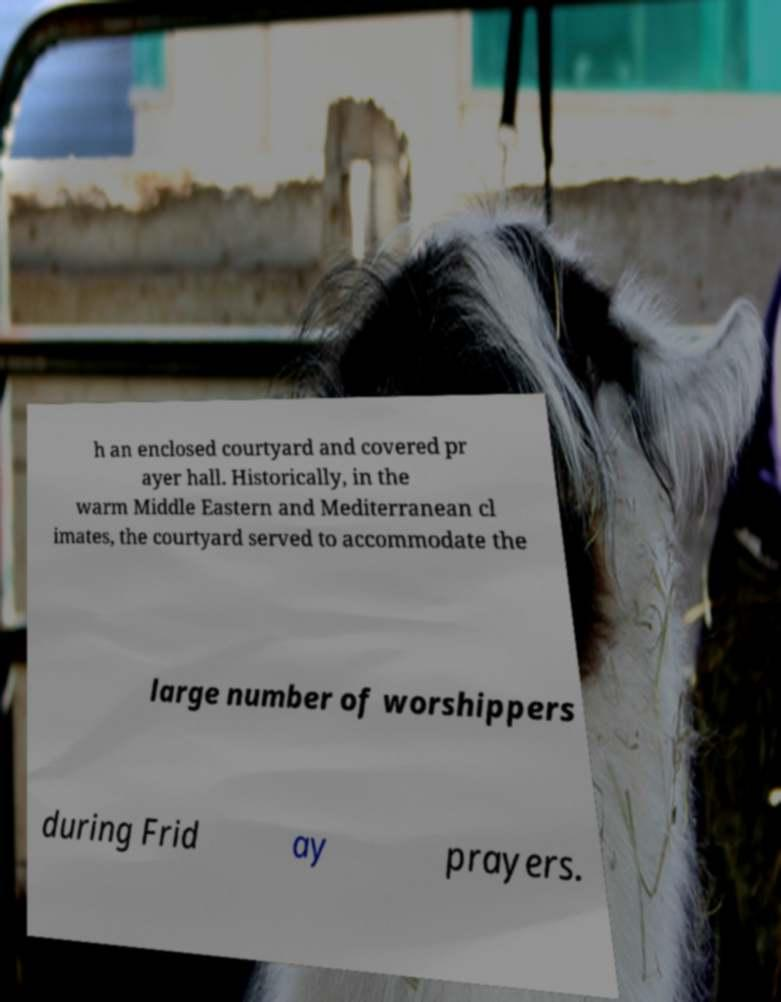For documentation purposes, I need the text within this image transcribed. Could you provide that? h an enclosed courtyard and covered pr ayer hall. Historically, in the warm Middle Eastern and Mediterranean cl imates, the courtyard served to accommodate the large number of worshippers during Frid ay prayers. 